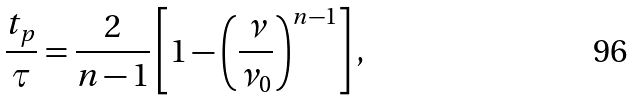<formula> <loc_0><loc_0><loc_500><loc_500>\frac { t _ { p } } { \tau } = \frac { 2 } { n - 1 } \left [ 1 - \left ( \frac { \nu } { \nu _ { 0 } } \right ) ^ { n - 1 } \right ] ,</formula> 